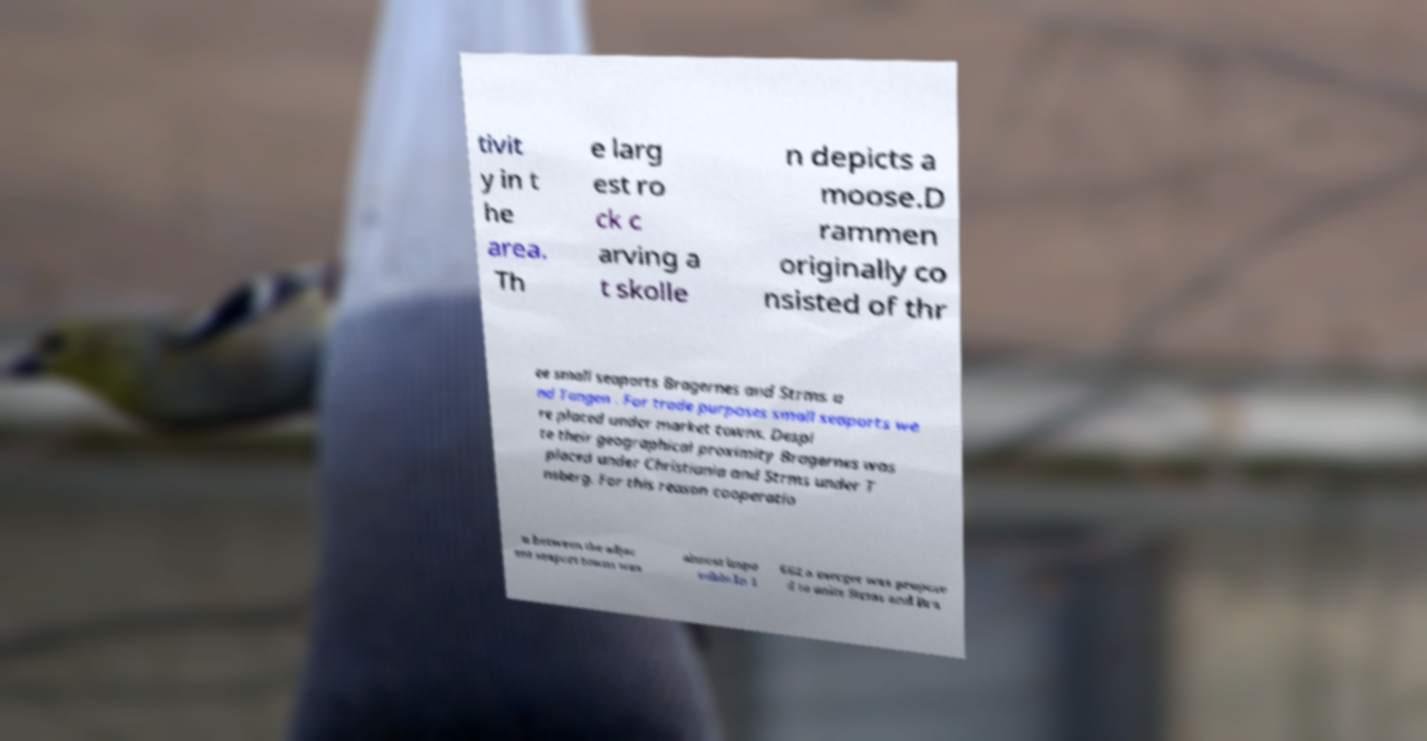Please read and relay the text visible in this image. What does it say? tivit y in t he area. Th e larg est ro ck c arving a t skolle n depicts a moose.D rammen originally co nsisted of thr ee small seaports Bragernes and Strms a nd Tangen . For trade purposes small seaports we re placed under market towns. Despi te their geographical proximity Bragernes was placed under Christiania and Strms under T nsberg. For this reason cooperatio n between the adjac ent seaport towns was almost impo ssible.In 1 662 a merger was propose d to unite Strms and Bra 